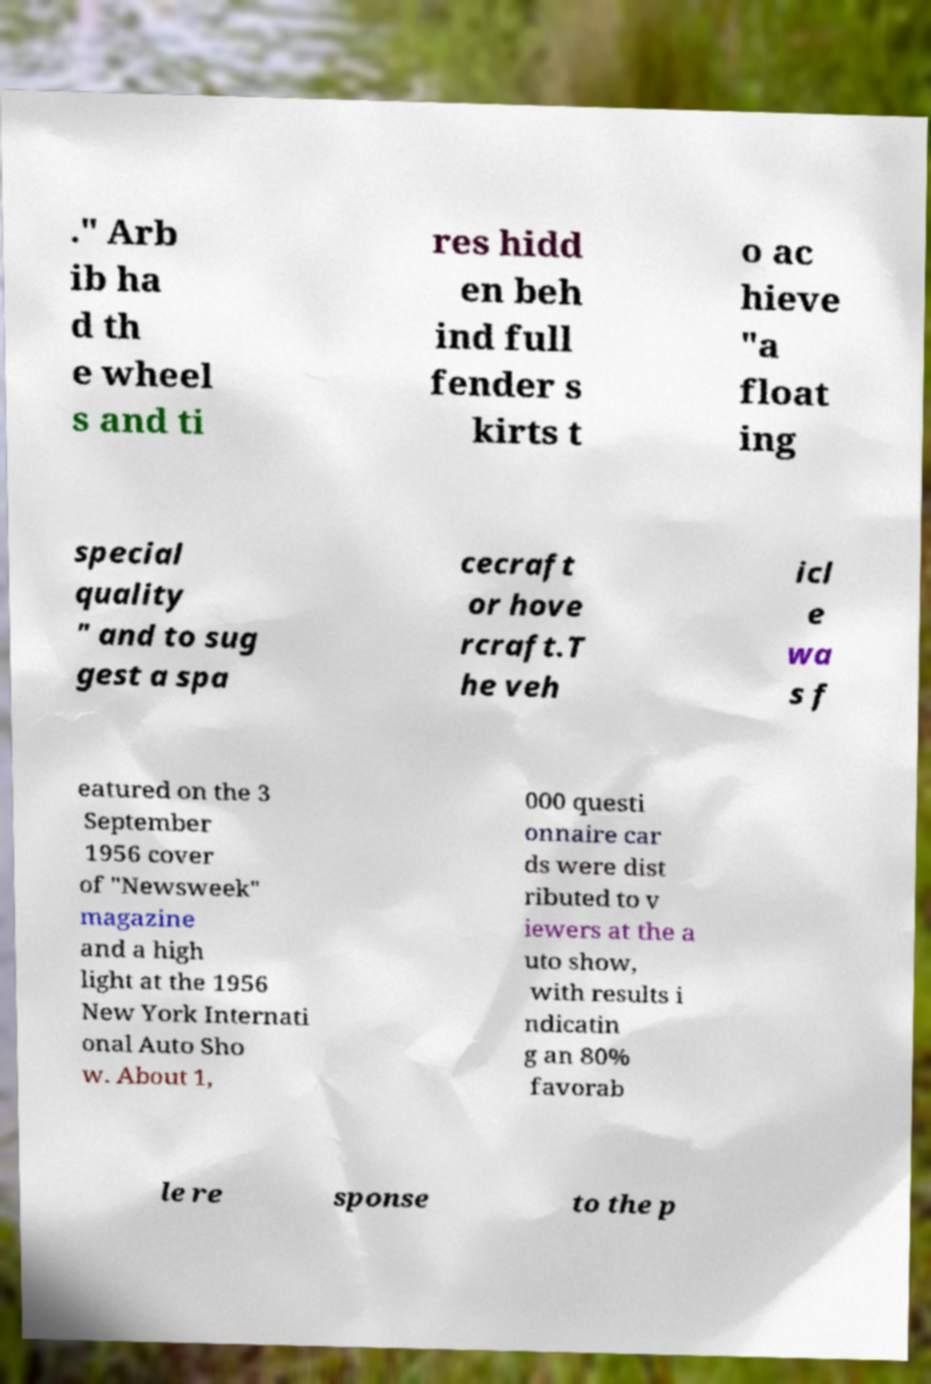Please read and relay the text visible in this image. What does it say? ." Arb ib ha d th e wheel s and ti res hidd en beh ind full fender s kirts t o ac hieve "a float ing special quality " and to sug gest a spa cecraft or hove rcraft.T he veh icl e wa s f eatured on the 3 September 1956 cover of "Newsweek" magazine and a high light at the 1956 New York Internati onal Auto Sho w. About 1, 000 questi onnaire car ds were dist ributed to v iewers at the a uto show, with results i ndicatin g an 80% favorab le re sponse to the p 